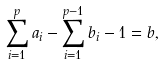<formula> <loc_0><loc_0><loc_500><loc_500>\sum _ { i = 1 } ^ { p } a _ { i } - \sum _ { i = 1 } ^ { p - 1 } b _ { i } - 1 = b ,</formula> 